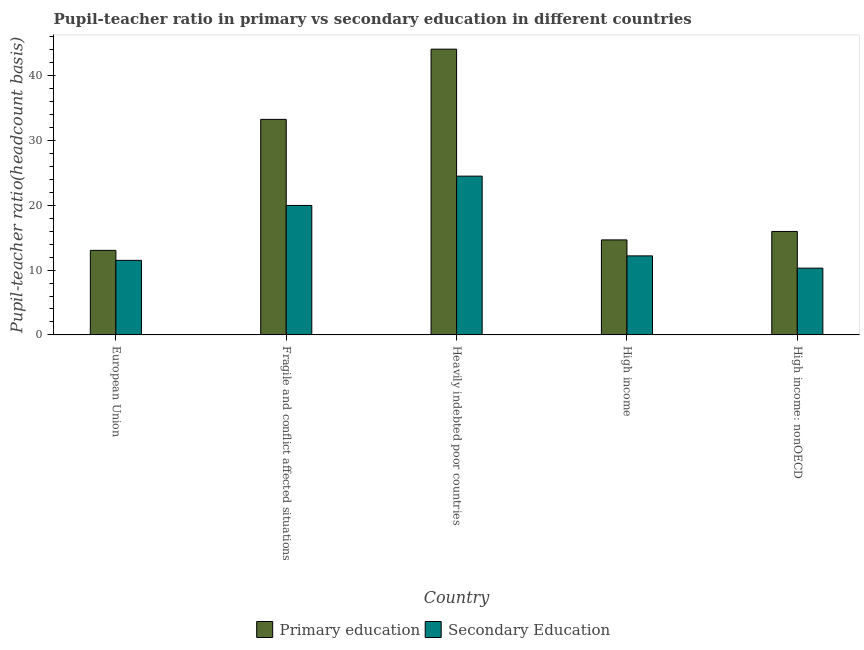How many different coloured bars are there?
Your answer should be very brief. 2. Are the number of bars on each tick of the X-axis equal?
Provide a succinct answer. Yes. How many bars are there on the 3rd tick from the left?
Your response must be concise. 2. In how many cases, is the number of bars for a given country not equal to the number of legend labels?
Give a very brief answer. 0. What is the pupil-teacher ratio in primary education in Fragile and conflict affected situations?
Your answer should be very brief. 33.25. Across all countries, what is the maximum pupil teacher ratio on secondary education?
Offer a terse response. 24.49. Across all countries, what is the minimum pupil teacher ratio on secondary education?
Make the answer very short. 10.3. In which country was the pupil teacher ratio on secondary education maximum?
Give a very brief answer. Heavily indebted poor countries. In which country was the pupil teacher ratio on secondary education minimum?
Offer a very short reply. High income: nonOECD. What is the total pupil teacher ratio on secondary education in the graph?
Your answer should be very brief. 78.45. What is the difference between the pupil-teacher ratio in primary education in Fragile and conflict affected situations and that in Heavily indebted poor countries?
Provide a succinct answer. -10.83. What is the difference between the pupil-teacher ratio in primary education in European Union and the pupil teacher ratio on secondary education in High income: nonOECD?
Provide a short and direct response. 2.74. What is the average pupil-teacher ratio in primary education per country?
Provide a short and direct response. 24.2. What is the difference between the pupil-teacher ratio in primary education and pupil teacher ratio on secondary education in High income: nonOECD?
Offer a very short reply. 5.66. In how many countries, is the pupil-teacher ratio in primary education greater than 18 ?
Offer a very short reply. 2. What is the ratio of the pupil-teacher ratio in primary education in High income to that in High income: nonOECD?
Your response must be concise. 0.92. Is the pupil-teacher ratio in primary education in Heavily indebted poor countries less than that in High income?
Give a very brief answer. No. What is the difference between the highest and the second highest pupil teacher ratio on secondary education?
Offer a terse response. 4.52. What is the difference between the highest and the lowest pupil-teacher ratio in primary education?
Offer a very short reply. 31.04. In how many countries, is the pupil-teacher ratio in primary education greater than the average pupil-teacher ratio in primary education taken over all countries?
Keep it short and to the point. 2. Is the sum of the pupil-teacher ratio in primary education in Heavily indebted poor countries and High income: nonOECD greater than the maximum pupil teacher ratio on secondary education across all countries?
Your answer should be very brief. Yes. What does the 1st bar from the right in European Union represents?
Make the answer very short. Secondary Education. How many bars are there?
Keep it short and to the point. 10. Are all the bars in the graph horizontal?
Ensure brevity in your answer.  No. How many countries are there in the graph?
Give a very brief answer. 5. What is the difference between two consecutive major ticks on the Y-axis?
Your answer should be compact. 10. Does the graph contain any zero values?
Offer a very short reply. No. Does the graph contain grids?
Provide a succinct answer. No. Where does the legend appear in the graph?
Your response must be concise. Bottom center. How many legend labels are there?
Your answer should be very brief. 2. How are the legend labels stacked?
Offer a very short reply. Horizontal. What is the title of the graph?
Ensure brevity in your answer.  Pupil-teacher ratio in primary vs secondary education in different countries. Does "Female population" appear as one of the legend labels in the graph?
Make the answer very short. No. What is the label or title of the X-axis?
Your answer should be compact. Country. What is the label or title of the Y-axis?
Provide a succinct answer. Pupil-teacher ratio(headcount basis). What is the Pupil-teacher ratio(headcount basis) of Primary education in European Union?
Offer a very short reply. 13.04. What is the Pupil-teacher ratio(headcount basis) of Secondary Education in European Union?
Keep it short and to the point. 11.5. What is the Pupil-teacher ratio(headcount basis) in Primary education in Fragile and conflict affected situations?
Provide a succinct answer. 33.25. What is the Pupil-teacher ratio(headcount basis) of Secondary Education in Fragile and conflict affected situations?
Provide a succinct answer. 19.97. What is the Pupil-teacher ratio(headcount basis) of Primary education in Heavily indebted poor countries?
Provide a succinct answer. 44.08. What is the Pupil-teacher ratio(headcount basis) of Secondary Education in Heavily indebted poor countries?
Keep it short and to the point. 24.49. What is the Pupil-teacher ratio(headcount basis) of Primary education in High income?
Make the answer very short. 14.66. What is the Pupil-teacher ratio(headcount basis) in Secondary Education in High income?
Offer a terse response. 12.19. What is the Pupil-teacher ratio(headcount basis) of Primary education in High income: nonOECD?
Your answer should be compact. 15.96. What is the Pupil-teacher ratio(headcount basis) of Secondary Education in High income: nonOECD?
Your answer should be compact. 10.3. Across all countries, what is the maximum Pupil-teacher ratio(headcount basis) in Primary education?
Your answer should be very brief. 44.08. Across all countries, what is the maximum Pupil-teacher ratio(headcount basis) in Secondary Education?
Make the answer very short. 24.49. Across all countries, what is the minimum Pupil-teacher ratio(headcount basis) of Primary education?
Your answer should be compact. 13.04. Across all countries, what is the minimum Pupil-teacher ratio(headcount basis) in Secondary Education?
Your answer should be compact. 10.3. What is the total Pupil-teacher ratio(headcount basis) in Primary education in the graph?
Keep it short and to the point. 120.99. What is the total Pupil-teacher ratio(headcount basis) of Secondary Education in the graph?
Your answer should be compact. 78.45. What is the difference between the Pupil-teacher ratio(headcount basis) in Primary education in European Union and that in Fragile and conflict affected situations?
Give a very brief answer. -20.21. What is the difference between the Pupil-teacher ratio(headcount basis) of Secondary Education in European Union and that in Fragile and conflict affected situations?
Make the answer very short. -8.47. What is the difference between the Pupil-teacher ratio(headcount basis) of Primary education in European Union and that in Heavily indebted poor countries?
Your answer should be compact. -31.04. What is the difference between the Pupil-teacher ratio(headcount basis) in Secondary Education in European Union and that in Heavily indebted poor countries?
Give a very brief answer. -12.99. What is the difference between the Pupil-teacher ratio(headcount basis) in Primary education in European Union and that in High income?
Keep it short and to the point. -1.61. What is the difference between the Pupil-teacher ratio(headcount basis) of Secondary Education in European Union and that in High income?
Ensure brevity in your answer.  -0.69. What is the difference between the Pupil-teacher ratio(headcount basis) of Primary education in European Union and that in High income: nonOECD?
Give a very brief answer. -2.92. What is the difference between the Pupil-teacher ratio(headcount basis) in Secondary Education in European Union and that in High income: nonOECD?
Ensure brevity in your answer.  1.2. What is the difference between the Pupil-teacher ratio(headcount basis) in Primary education in Fragile and conflict affected situations and that in Heavily indebted poor countries?
Your response must be concise. -10.83. What is the difference between the Pupil-teacher ratio(headcount basis) of Secondary Education in Fragile and conflict affected situations and that in Heavily indebted poor countries?
Keep it short and to the point. -4.52. What is the difference between the Pupil-teacher ratio(headcount basis) of Primary education in Fragile and conflict affected situations and that in High income?
Keep it short and to the point. 18.59. What is the difference between the Pupil-teacher ratio(headcount basis) of Secondary Education in Fragile and conflict affected situations and that in High income?
Provide a succinct answer. 7.78. What is the difference between the Pupil-teacher ratio(headcount basis) of Primary education in Fragile and conflict affected situations and that in High income: nonOECD?
Your answer should be compact. 17.29. What is the difference between the Pupil-teacher ratio(headcount basis) in Secondary Education in Fragile and conflict affected situations and that in High income: nonOECD?
Offer a very short reply. 9.67. What is the difference between the Pupil-teacher ratio(headcount basis) in Primary education in Heavily indebted poor countries and that in High income?
Offer a very short reply. 29.42. What is the difference between the Pupil-teacher ratio(headcount basis) in Secondary Education in Heavily indebted poor countries and that in High income?
Provide a short and direct response. 12.3. What is the difference between the Pupil-teacher ratio(headcount basis) in Primary education in Heavily indebted poor countries and that in High income: nonOECD?
Offer a terse response. 28.12. What is the difference between the Pupil-teacher ratio(headcount basis) of Secondary Education in Heavily indebted poor countries and that in High income: nonOECD?
Your answer should be compact. 14.19. What is the difference between the Pupil-teacher ratio(headcount basis) in Primary education in High income and that in High income: nonOECD?
Ensure brevity in your answer.  -1.3. What is the difference between the Pupil-teacher ratio(headcount basis) in Secondary Education in High income and that in High income: nonOECD?
Give a very brief answer. 1.89. What is the difference between the Pupil-teacher ratio(headcount basis) in Primary education in European Union and the Pupil-teacher ratio(headcount basis) in Secondary Education in Fragile and conflict affected situations?
Provide a succinct answer. -6.93. What is the difference between the Pupil-teacher ratio(headcount basis) in Primary education in European Union and the Pupil-teacher ratio(headcount basis) in Secondary Education in Heavily indebted poor countries?
Ensure brevity in your answer.  -11.45. What is the difference between the Pupil-teacher ratio(headcount basis) of Primary education in European Union and the Pupil-teacher ratio(headcount basis) of Secondary Education in High income?
Your answer should be very brief. 0.85. What is the difference between the Pupil-teacher ratio(headcount basis) in Primary education in European Union and the Pupil-teacher ratio(headcount basis) in Secondary Education in High income: nonOECD?
Provide a short and direct response. 2.74. What is the difference between the Pupil-teacher ratio(headcount basis) of Primary education in Fragile and conflict affected situations and the Pupil-teacher ratio(headcount basis) of Secondary Education in Heavily indebted poor countries?
Offer a terse response. 8.76. What is the difference between the Pupil-teacher ratio(headcount basis) in Primary education in Fragile and conflict affected situations and the Pupil-teacher ratio(headcount basis) in Secondary Education in High income?
Ensure brevity in your answer.  21.06. What is the difference between the Pupil-teacher ratio(headcount basis) of Primary education in Fragile and conflict affected situations and the Pupil-teacher ratio(headcount basis) of Secondary Education in High income: nonOECD?
Your response must be concise. 22.95. What is the difference between the Pupil-teacher ratio(headcount basis) of Primary education in Heavily indebted poor countries and the Pupil-teacher ratio(headcount basis) of Secondary Education in High income?
Provide a succinct answer. 31.89. What is the difference between the Pupil-teacher ratio(headcount basis) in Primary education in Heavily indebted poor countries and the Pupil-teacher ratio(headcount basis) in Secondary Education in High income: nonOECD?
Your answer should be very brief. 33.78. What is the difference between the Pupil-teacher ratio(headcount basis) in Primary education in High income and the Pupil-teacher ratio(headcount basis) in Secondary Education in High income: nonOECD?
Give a very brief answer. 4.36. What is the average Pupil-teacher ratio(headcount basis) of Primary education per country?
Keep it short and to the point. 24.2. What is the average Pupil-teacher ratio(headcount basis) in Secondary Education per country?
Your answer should be compact. 15.69. What is the difference between the Pupil-teacher ratio(headcount basis) in Primary education and Pupil-teacher ratio(headcount basis) in Secondary Education in European Union?
Your response must be concise. 1.54. What is the difference between the Pupil-teacher ratio(headcount basis) of Primary education and Pupil-teacher ratio(headcount basis) of Secondary Education in Fragile and conflict affected situations?
Provide a succinct answer. 13.28. What is the difference between the Pupil-teacher ratio(headcount basis) in Primary education and Pupil-teacher ratio(headcount basis) in Secondary Education in Heavily indebted poor countries?
Give a very brief answer. 19.59. What is the difference between the Pupil-teacher ratio(headcount basis) of Primary education and Pupil-teacher ratio(headcount basis) of Secondary Education in High income?
Provide a succinct answer. 2.46. What is the difference between the Pupil-teacher ratio(headcount basis) of Primary education and Pupil-teacher ratio(headcount basis) of Secondary Education in High income: nonOECD?
Give a very brief answer. 5.66. What is the ratio of the Pupil-teacher ratio(headcount basis) of Primary education in European Union to that in Fragile and conflict affected situations?
Your answer should be very brief. 0.39. What is the ratio of the Pupil-teacher ratio(headcount basis) in Secondary Education in European Union to that in Fragile and conflict affected situations?
Your answer should be compact. 0.58. What is the ratio of the Pupil-teacher ratio(headcount basis) of Primary education in European Union to that in Heavily indebted poor countries?
Give a very brief answer. 0.3. What is the ratio of the Pupil-teacher ratio(headcount basis) of Secondary Education in European Union to that in Heavily indebted poor countries?
Your response must be concise. 0.47. What is the ratio of the Pupil-teacher ratio(headcount basis) of Primary education in European Union to that in High income?
Give a very brief answer. 0.89. What is the ratio of the Pupil-teacher ratio(headcount basis) of Secondary Education in European Union to that in High income?
Ensure brevity in your answer.  0.94. What is the ratio of the Pupil-teacher ratio(headcount basis) in Primary education in European Union to that in High income: nonOECD?
Your answer should be compact. 0.82. What is the ratio of the Pupil-teacher ratio(headcount basis) of Secondary Education in European Union to that in High income: nonOECD?
Offer a very short reply. 1.12. What is the ratio of the Pupil-teacher ratio(headcount basis) of Primary education in Fragile and conflict affected situations to that in Heavily indebted poor countries?
Provide a short and direct response. 0.75. What is the ratio of the Pupil-teacher ratio(headcount basis) in Secondary Education in Fragile and conflict affected situations to that in Heavily indebted poor countries?
Keep it short and to the point. 0.82. What is the ratio of the Pupil-teacher ratio(headcount basis) of Primary education in Fragile and conflict affected situations to that in High income?
Your answer should be very brief. 2.27. What is the ratio of the Pupil-teacher ratio(headcount basis) in Secondary Education in Fragile and conflict affected situations to that in High income?
Offer a very short reply. 1.64. What is the ratio of the Pupil-teacher ratio(headcount basis) in Primary education in Fragile and conflict affected situations to that in High income: nonOECD?
Make the answer very short. 2.08. What is the ratio of the Pupil-teacher ratio(headcount basis) in Secondary Education in Fragile and conflict affected situations to that in High income: nonOECD?
Make the answer very short. 1.94. What is the ratio of the Pupil-teacher ratio(headcount basis) of Primary education in Heavily indebted poor countries to that in High income?
Make the answer very short. 3.01. What is the ratio of the Pupil-teacher ratio(headcount basis) of Secondary Education in Heavily indebted poor countries to that in High income?
Offer a very short reply. 2.01. What is the ratio of the Pupil-teacher ratio(headcount basis) in Primary education in Heavily indebted poor countries to that in High income: nonOECD?
Your answer should be compact. 2.76. What is the ratio of the Pupil-teacher ratio(headcount basis) in Secondary Education in Heavily indebted poor countries to that in High income: nonOECD?
Provide a succinct answer. 2.38. What is the ratio of the Pupil-teacher ratio(headcount basis) of Primary education in High income to that in High income: nonOECD?
Offer a terse response. 0.92. What is the ratio of the Pupil-teacher ratio(headcount basis) in Secondary Education in High income to that in High income: nonOECD?
Provide a succinct answer. 1.18. What is the difference between the highest and the second highest Pupil-teacher ratio(headcount basis) in Primary education?
Provide a short and direct response. 10.83. What is the difference between the highest and the second highest Pupil-teacher ratio(headcount basis) of Secondary Education?
Your response must be concise. 4.52. What is the difference between the highest and the lowest Pupil-teacher ratio(headcount basis) of Primary education?
Provide a short and direct response. 31.04. What is the difference between the highest and the lowest Pupil-teacher ratio(headcount basis) of Secondary Education?
Give a very brief answer. 14.19. 